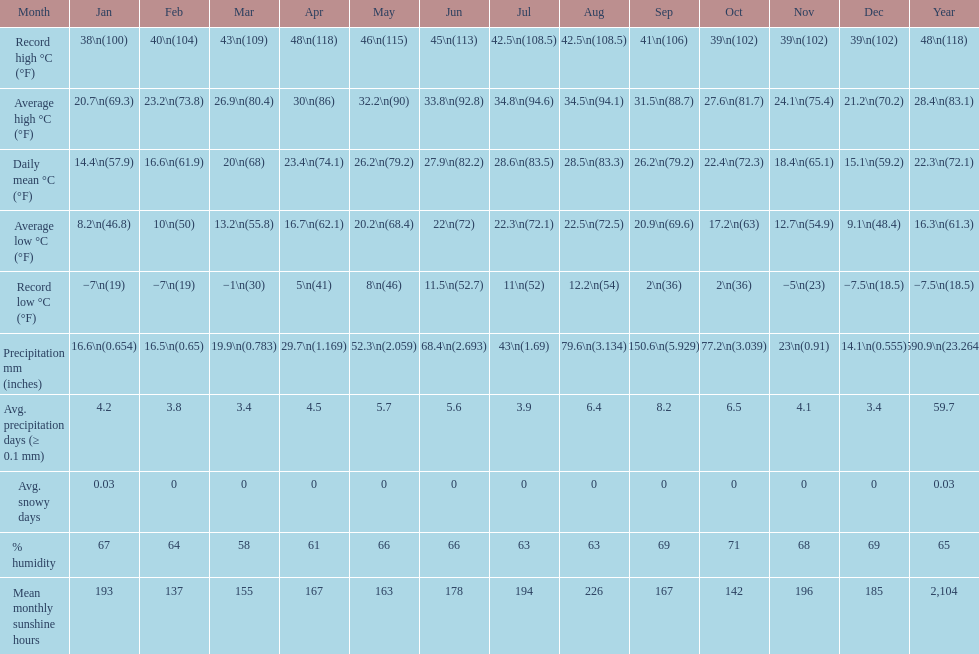Did march or april experience more rainfall? April. 